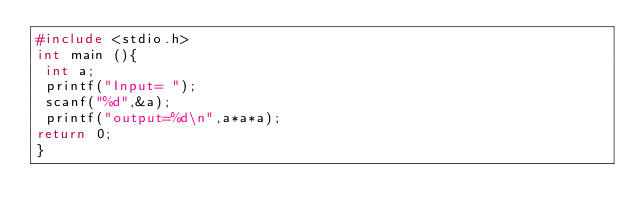Convert code to text. <code><loc_0><loc_0><loc_500><loc_500><_C++_>#include <stdio.h>
int main (){
 int a;
 printf("Input= ");
 scanf("%d",&a);
 printf("output=%d\n",a*a*a); 
return 0;
}</code> 